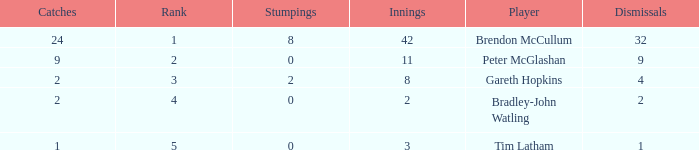List the ranks of all dismissals with a value of 4 3.0. 